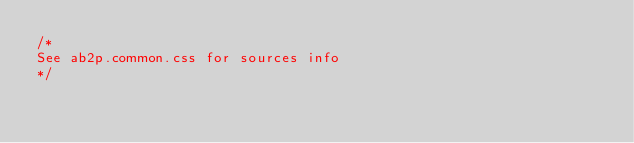Convert code to text. <code><loc_0><loc_0><loc_500><loc_500><_CSS_>/*
See ab2p.common.css for sources info
*/</code> 